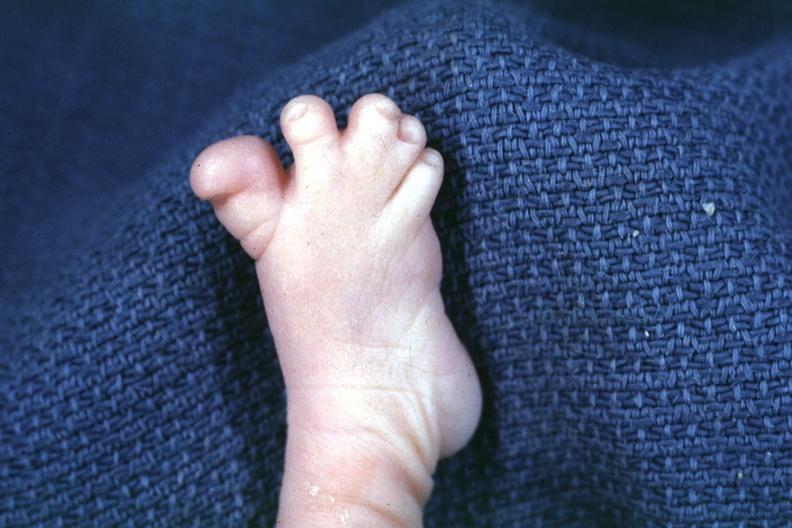what does this image show?
Answer the question using a single word or phrase. Nice photo of syndactyly 